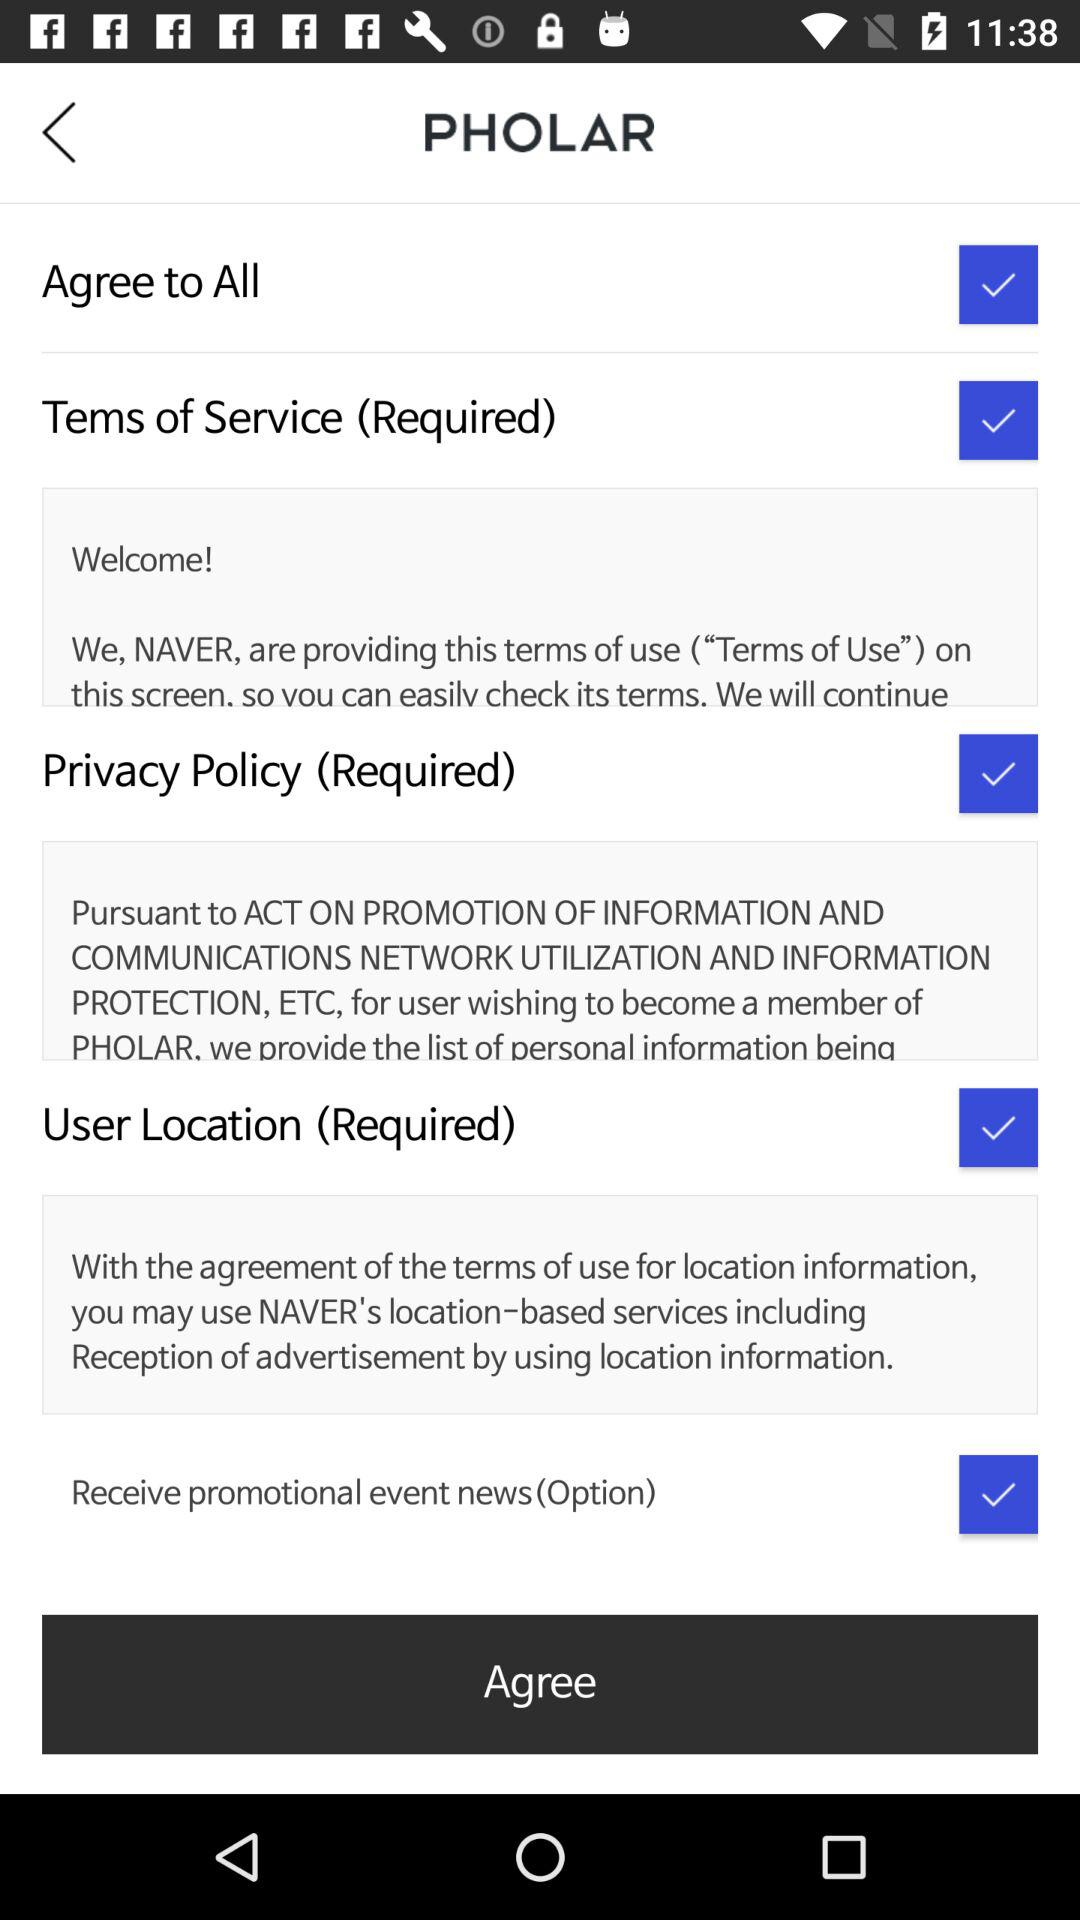What is the selected checkbox? The selected checkbox are "Agree to All", "Tems of Service (Required)", "Privacy Policy (Required)", "User Location (Required)" and "Receive promotional event news (Option)". 